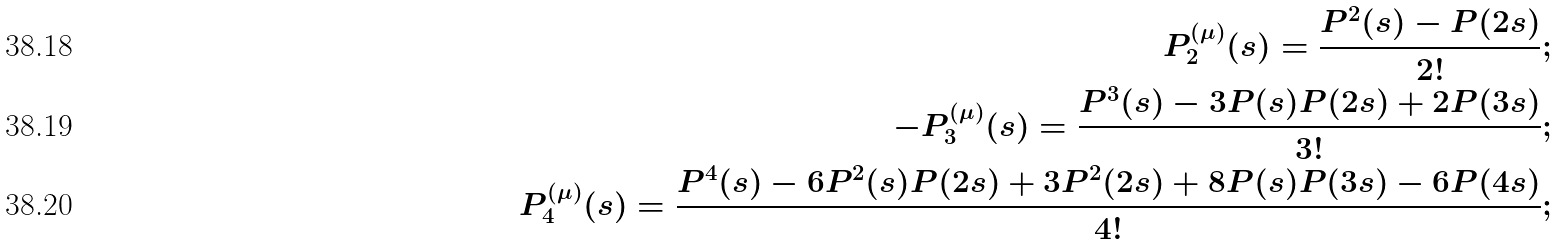Convert formula to latex. <formula><loc_0><loc_0><loc_500><loc_500>P _ { 2 } ^ { ( \mu ) } ( s ) = \frac { P ^ { 2 } ( s ) - P ( 2 s ) } { 2 ! } ; \\ - P _ { 3 } ^ { ( \mu ) } ( s ) = \frac { P ^ { 3 } ( s ) - 3 P ( s ) P ( 2 s ) + 2 P ( 3 s ) } { 3 ! } ; \\ P _ { 4 } ^ { ( \mu ) } ( s ) = \frac { P ^ { 4 } ( s ) - 6 P ^ { 2 } ( s ) P ( 2 s ) + 3 P ^ { 2 } ( 2 s ) + 8 P ( s ) P ( 3 s ) - 6 P ( 4 s ) } { 4 ! } ;</formula> 